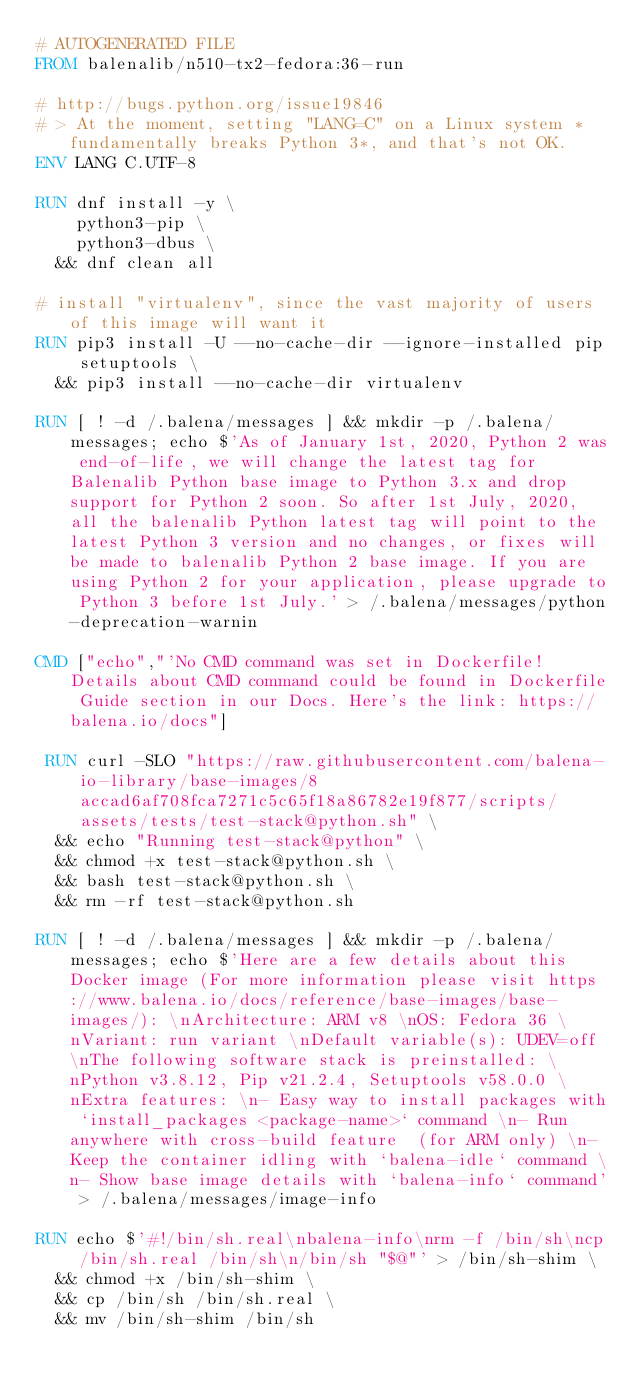<code> <loc_0><loc_0><loc_500><loc_500><_Dockerfile_># AUTOGENERATED FILE
FROM balenalib/n510-tx2-fedora:36-run

# http://bugs.python.org/issue19846
# > At the moment, setting "LANG=C" on a Linux system *fundamentally breaks Python 3*, and that's not OK.
ENV LANG C.UTF-8

RUN dnf install -y \
		python3-pip \
		python3-dbus \
	&& dnf clean all

# install "virtualenv", since the vast majority of users of this image will want it
RUN pip3 install -U --no-cache-dir --ignore-installed pip setuptools \
	&& pip3 install --no-cache-dir virtualenv

RUN [ ! -d /.balena/messages ] && mkdir -p /.balena/messages; echo $'As of January 1st, 2020, Python 2 was end-of-life, we will change the latest tag for Balenalib Python base image to Python 3.x and drop support for Python 2 soon. So after 1st July, 2020, all the balenalib Python latest tag will point to the latest Python 3 version and no changes, or fixes will be made to balenalib Python 2 base image. If you are using Python 2 for your application, please upgrade to Python 3 before 1st July.' > /.balena/messages/python-deprecation-warnin

CMD ["echo","'No CMD command was set in Dockerfile! Details about CMD command could be found in Dockerfile Guide section in our Docs. Here's the link: https://balena.io/docs"]

 RUN curl -SLO "https://raw.githubusercontent.com/balena-io-library/base-images/8accad6af708fca7271c5c65f18a86782e19f877/scripts/assets/tests/test-stack@python.sh" \
  && echo "Running test-stack@python" \
  && chmod +x test-stack@python.sh \
  && bash test-stack@python.sh \
  && rm -rf test-stack@python.sh 

RUN [ ! -d /.balena/messages ] && mkdir -p /.balena/messages; echo $'Here are a few details about this Docker image (For more information please visit https://www.balena.io/docs/reference/base-images/base-images/): \nArchitecture: ARM v8 \nOS: Fedora 36 \nVariant: run variant \nDefault variable(s): UDEV=off \nThe following software stack is preinstalled: \nPython v3.8.12, Pip v21.2.4, Setuptools v58.0.0 \nExtra features: \n- Easy way to install packages with `install_packages <package-name>` command \n- Run anywhere with cross-build feature  (for ARM only) \n- Keep the container idling with `balena-idle` command \n- Show base image details with `balena-info` command' > /.balena/messages/image-info

RUN echo $'#!/bin/sh.real\nbalena-info\nrm -f /bin/sh\ncp /bin/sh.real /bin/sh\n/bin/sh "$@"' > /bin/sh-shim \
	&& chmod +x /bin/sh-shim \
	&& cp /bin/sh /bin/sh.real \
	&& mv /bin/sh-shim /bin/sh</code> 